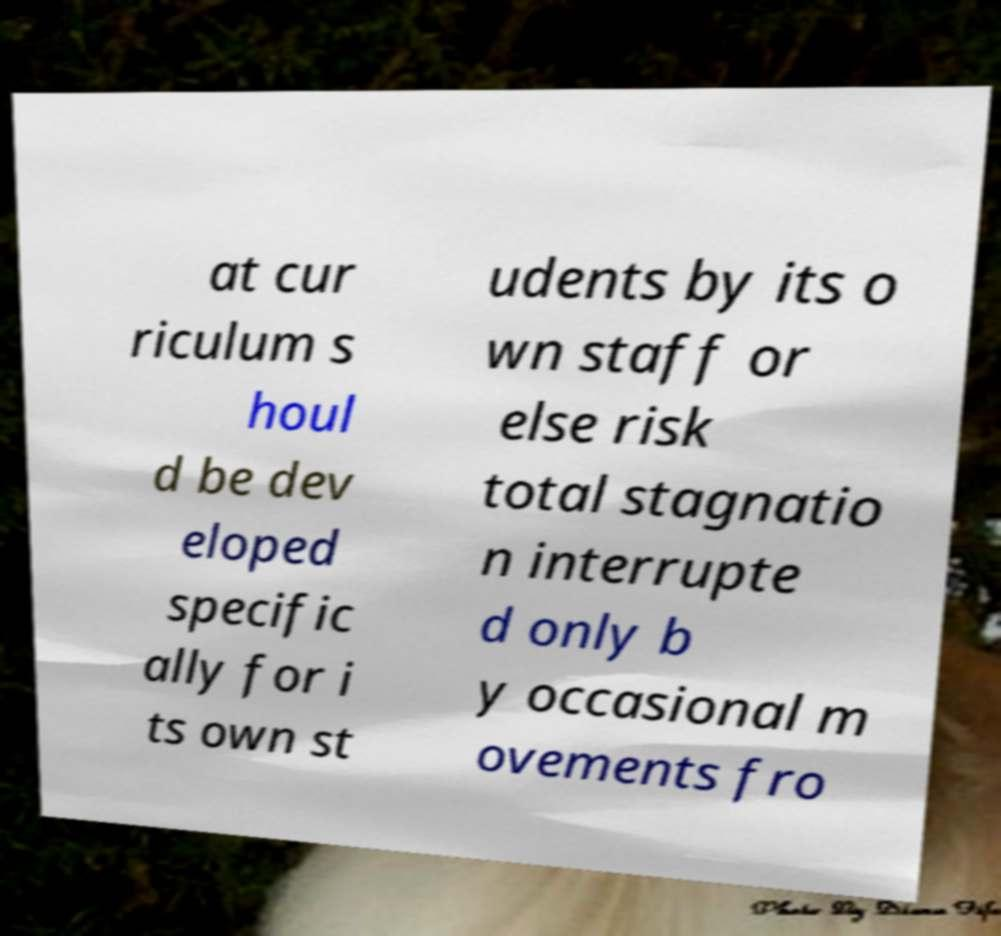Can you read and provide the text displayed in the image?This photo seems to have some interesting text. Can you extract and type it out for me? at cur riculum s houl d be dev eloped specific ally for i ts own st udents by its o wn staff or else risk total stagnatio n interrupte d only b y occasional m ovements fro 